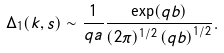Convert formula to latex. <formula><loc_0><loc_0><loc_500><loc_500>\Delta _ { 1 } ( k , s ) \sim \frac { 1 } { q a } \frac { \exp ( q b ) } { ( 2 \pi ) ^ { 1 / 2 } \left ( q b \right ) ^ { 1 / 2 } } .</formula> 